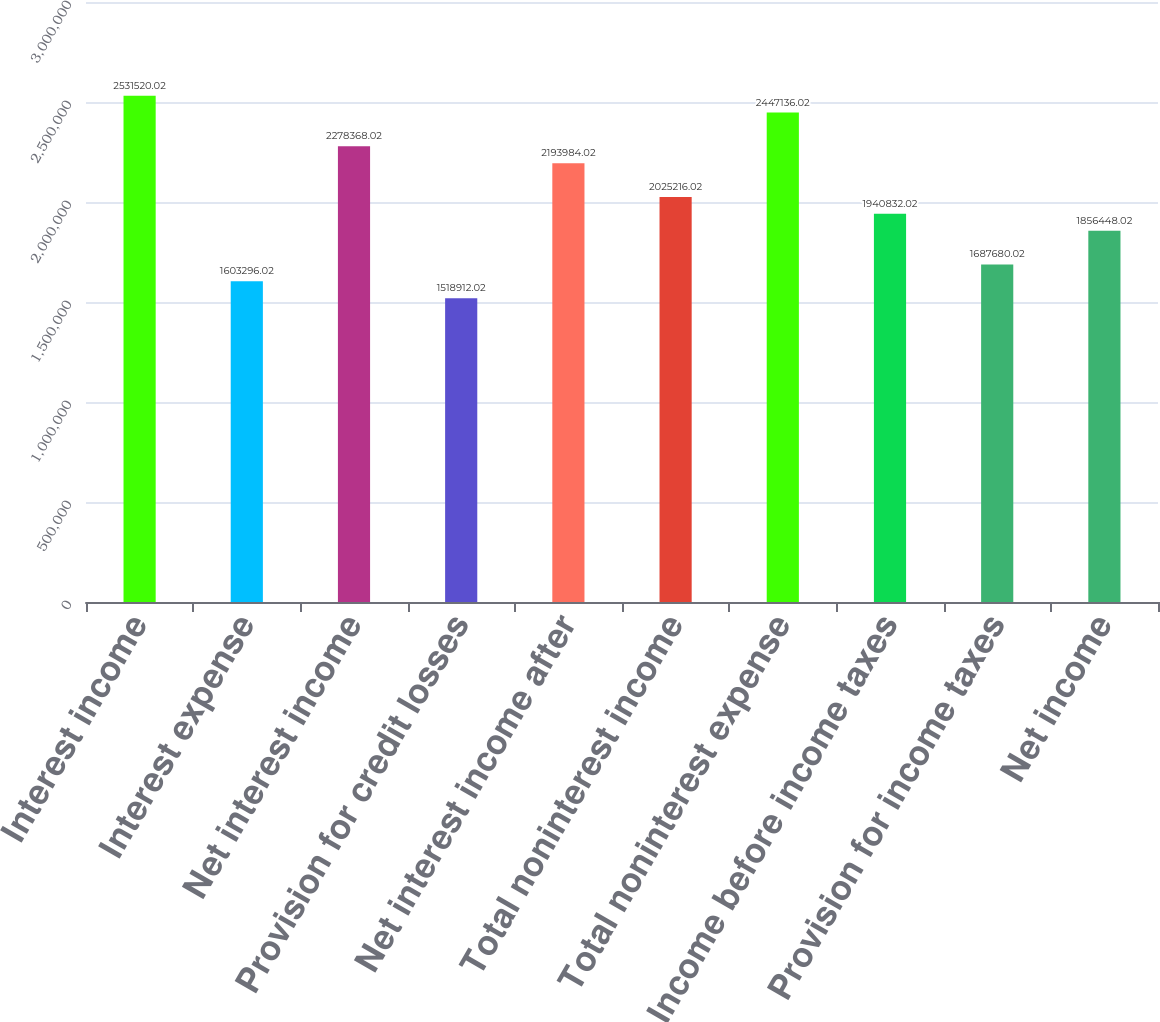Convert chart. <chart><loc_0><loc_0><loc_500><loc_500><bar_chart><fcel>Interest income<fcel>Interest expense<fcel>Net interest income<fcel>Provision for credit losses<fcel>Net interest income after<fcel>Total noninterest income<fcel>Total noninterest expense<fcel>Income before income taxes<fcel>Provision for income taxes<fcel>Net income<nl><fcel>2.53152e+06<fcel>1.6033e+06<fcel>2.27837e+06<fcel>1.51891e+06<fcel>2.19398e+06<fcel>2.02522e+06<fcel>2.44714e+06<fcel>1.94083e+06<fcel>1.68768e+06<fcel>1.85645e+06<nl></chart> 